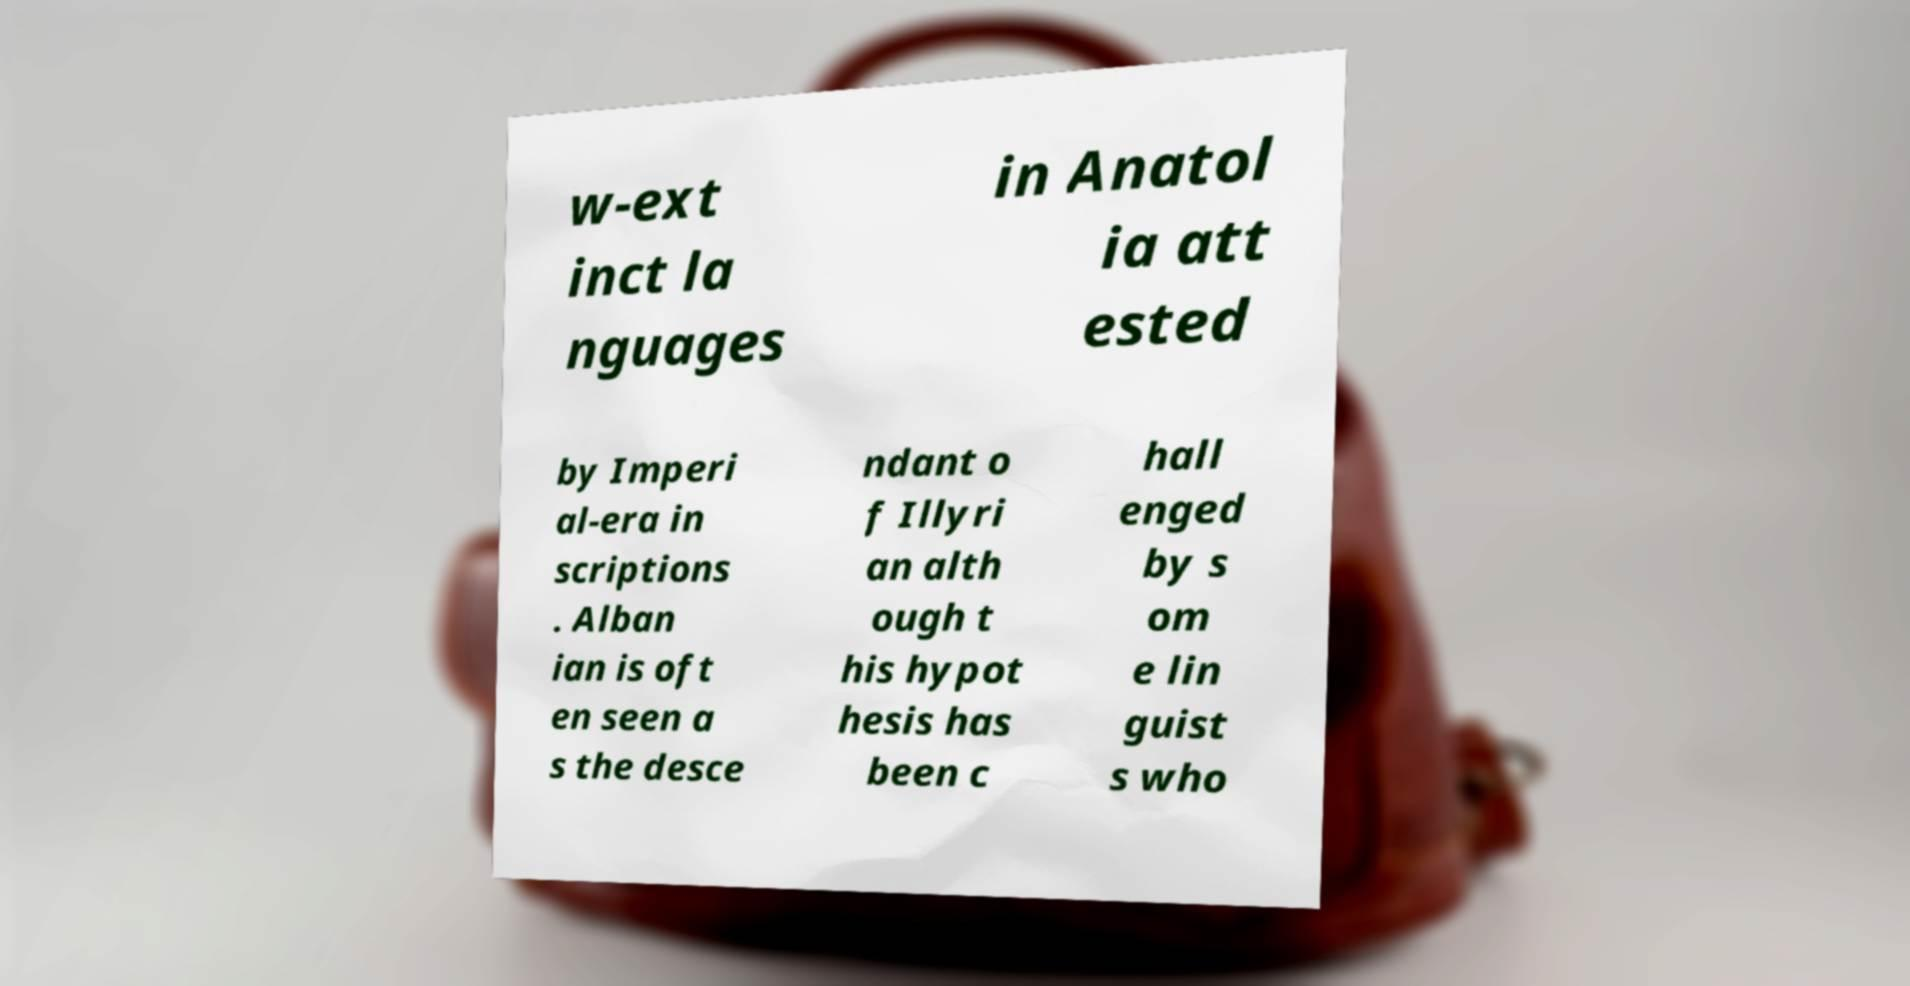There's text embedded in this image that I need extracted. Can you transcribe it verbatim? w-ext inct la nguages in Anatol ia att ested by Imperi al-era in scriptions . Alban ian is oft en seen a s the desce ndant o f Illyri an alth ough t his hypot hesis has been c hall enged by s om e lin guist s who 